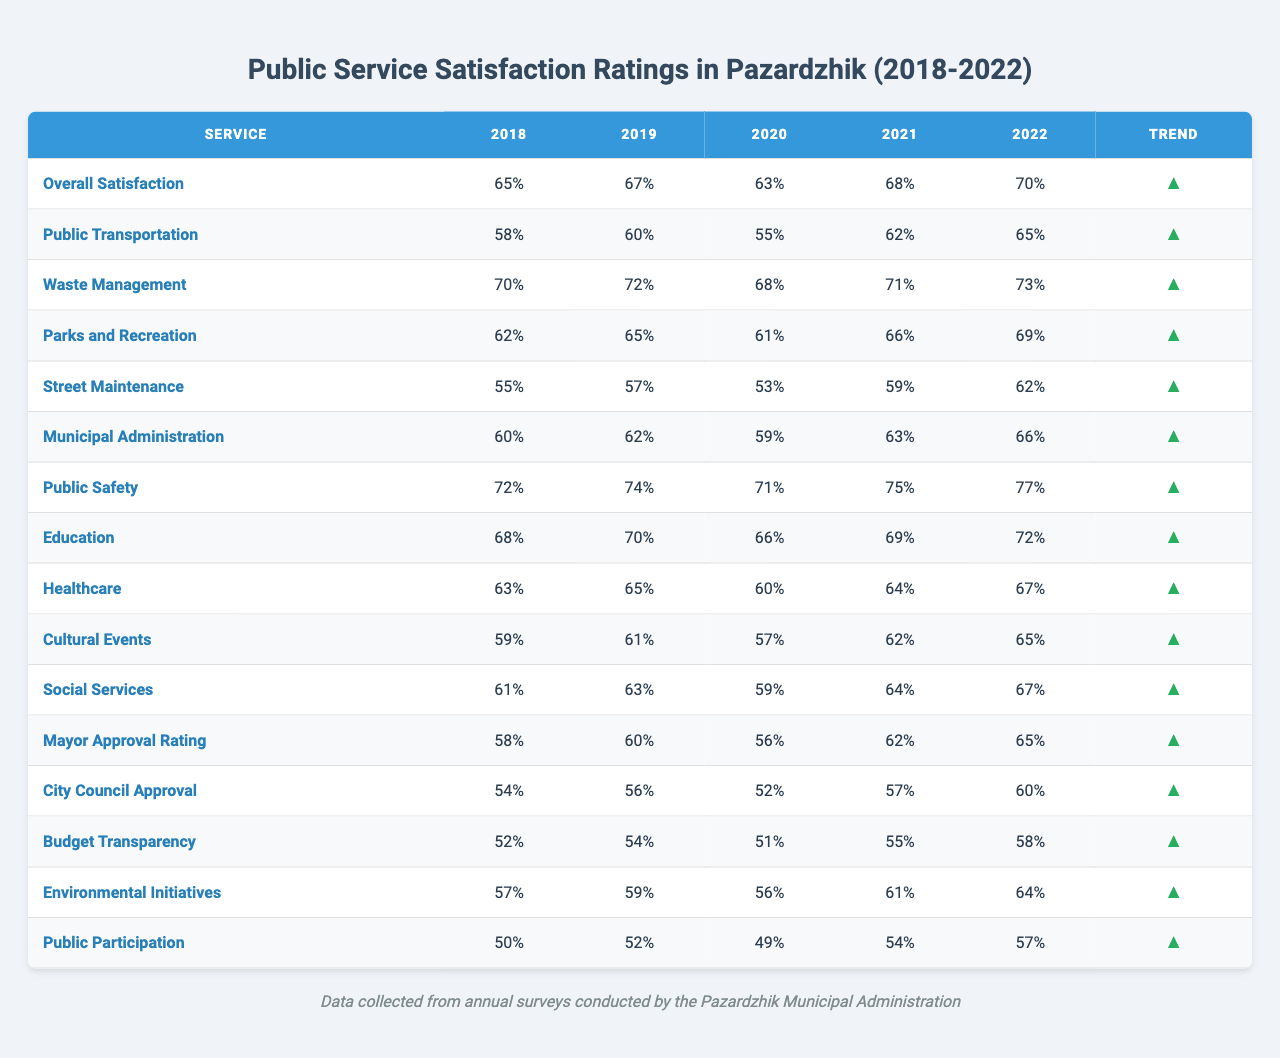What's the overall satisfaction rating in 2022? According to the table, the overall satisfaction rating for 2022 is directly listed as 70.
Answer: 70 Which public service had the highest satisfaction rating in 2020? Looking at the ratings for 2020, Waste Management had the highest score of 68.
Answer: Waste Management Did public safety satisfaction ratings improve over the five years? Yes, the public safety ratings started at 72 in 2018 and increased to 77 in 2022, indicating an improvement over the five years.
Answer: Yes What was the increase in satisfaction for street maintenance from 2018 to 2022? Street maintenance ratings were 55 in 2018 and 62 in 2022. The increase can be calculated as 62 - 55 = 7.
Answer: 7 Which service showed the least improvement over the five years? Looking at the trends, Public Participation started at 50 in 2018 and increased to 57 in 2022, showing an increase of only 7. This is less than others.
Answer: Public Participation Is the satisfaction rating for Waste Management higher than that of Public Transportation in 2021? In 2021, Waste Management had a rating of 71, while Public Transportation had a rating of 62, confirming that Waste Management's rating is higher.
Answer: Yes What is the average satisfaction rating for Public Safety over the five years? The ratings for Public Safety are 72, 74, 71, 75, and 77. Adding them gives 369, and dividing by 5 gives an average of 73.8.
Answer: 73.8 Did the Mayor's Approval Rating increase each year from 2018 to 2022? By reviewing the ratings, we can see they were 58, 60, 56, 62, and 65, meaning there was a drop from 2019 to 2020, so it did not increase each year.
Answer: No What year had the highest satisfaction rating for Education? The Education rating shows its highest value of 72 in 2022.
Answer: 2022 In which area did Pazardzhik residents show the most satisfaction in 2019? In 2019, the highest satisfaction rating was in Public Safety with a score of 74.
Answer: Public Safety 